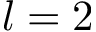Convert formula to latex. <formula><loc_0><loc_0><loc_500><loc_500>l = 2</formula> 